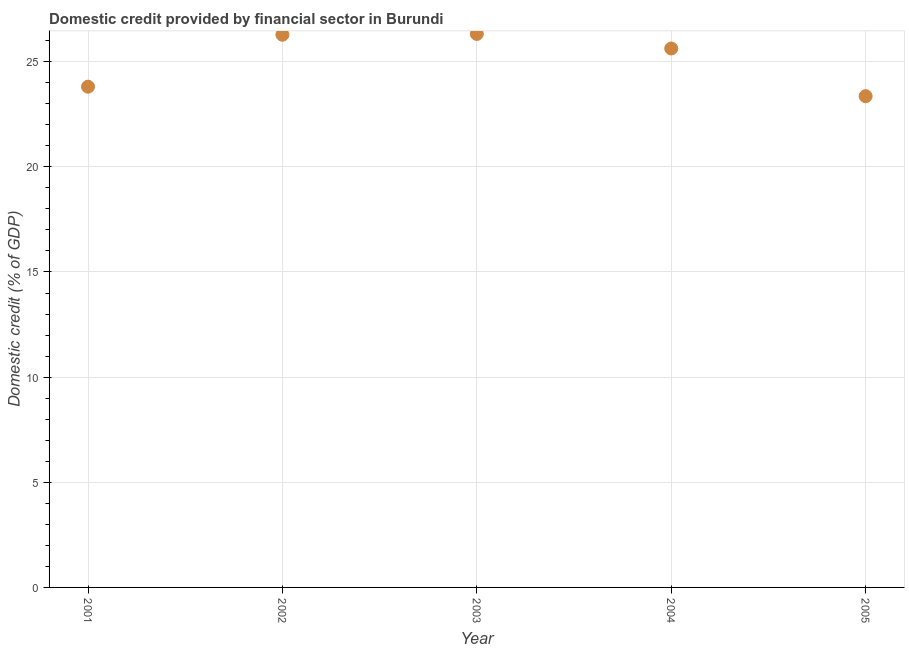What is the domestic credit provided by financial sector in 2002?
Offer a very short reply. 26.28. Across all years, what is the maximum domestic credit provided by financial sector?
Your response must be concise. 26.32. Across all years, what is the minimum domestic credit provided by financial sector?
Make the answer very short. 23.36. What is the sum of the domestic credit provided by financial sector?
Keep it short and to the point. 125.4. What is the difference between the domestic credit provided by financial sector in 2003 and 2004?
Your answer should be very brief. 0.69. What is the average domestic credit provided by financial sector per year?
Ensure brevity in your answer.  25.08. What is the median domestic credit provided by financial sector?
Your answer should be compact. 25.63. In how many years, is the domestic credit provided by financial sector greater than 1 %?
Ensure brevity in your answer.  5. What is the ratio of the domestic credit provided by financial sector in 2002 to that in 2004?
Provide a short and direct response. 1.03. Is the domestic credit provided by financial sector in 2001 less than that in 2003?
Your answer should be very brief. Yes. What is the difference between the highest and the second highest domestic credit provided by financial sector?
Your answer should be very brief. 0.04. What is the difference between the highest and the lowest domestic credit provided by financial sector?
Ensure brevity in your answer.  2.96. How many dotlines are there?
Keep it short and to the point. 1. How many years are there in the graph?
Your response must be concise. 5. What is the title of the graph?
Ensure brevity in your answer.  Domestic credit provided by financial sector in Burundi. What is the label or title of the X-axis?
Provide a succinct answer. Year. What is the label or title of the Y-axis?
Ensure brevity in your answer.  Domestic credit (% of GDP). What is the Domestic credit (% of GDP) in 2001?
Ensure brevity in your answer.  23.81. What is the Domestic credit (% of GDP) in 2002?
Ensure brevity in your answer.  26.28. What is the Domestic credit (% of GDP) in 2003?
Keep it short and to the point. 26.32. What is the Domestic credit (% of GDP) in 2004?
Give a very brief answer. 25.63. What is the Domestic credit (% of GDP) in 2005?
Give a very brief answer. 23.36. What is the difference between the Domestic credit (% of GDP) in 2001 and 2002?
Offer a terse response. -2.47. What is the difference between the Domestic credit (% of GDP) in 2001 and 2003?
Offer a terse response. -2.51. What is the difference between the Domestic credit (% of GDP) in 2001 and 2004?
Provide a short and direct response. -1.82. What is the difference between the Domestic credit (% of GDP) in 2001 and 2005?
Make the answer very short. 0.45. What is the difference between the Domestic credit (% of GDP) in 2002 and 2003?
Make the answer very short. -0.04. What is the difference between the Domestic credit (% of GDP) in 2002 and 2004?
Make the answer very short. 0.65. What is the difference between the Domestic credit (% of GDP) in 2002 and 2005?
Make the answer very short. 2.92. What is the difference between the Domestic credit (% of GDP) in 2003 and 2004?
Offer a terse response. 0.69. What is the difference between the Domestic credit (% of GDP) in 2003 and 2005?
Provide a succinct answer. 2.96. What is the difference between the Domestic credit (% of GDP) in 2004 and 2005?
Give a very brief answer. 2.27. What is the ratio of the Domestic credit (% of GDP) in 2001 to that in 2002?
Keep it short and to the point. 0.91. What is the ratio of the Domestic credit (% of GDP) in 2001 to that in 2003?
Offer a terse response. 0.91. What is the ratio of the Domestic credit (% of GDP) in 2001 to that in 2004?
Your answer should be compact. 0.93. What is the ratio of the Domestic credit (% of GDP) in 2001 to that in 2005?
Offer a very short reply. 1.02. What is the ratio of the Domestic credit (% of GDP) in 2002 to that in 2003?
Give a very brief answer. 1. What is the ratio of the Domestic credit (% of GDP) in 2002 to that in 2004?
Your response must be concise. 1.03. What is the ratio of the Domestic credit (% of GDP) in 2002 to that in 2005?
Make the answer very short. 1.12. What is the ratio of the Domestic credit (% of GDP) in 2003 to that in 2004?
Provide a short and direct response. 1.03. What is the ratio of the Domestic credit (% of GDP) in 2003 to that in 2005?
Offer a terse response. 1.13. What is the ratio of the Domestic credit (% of GDP) in 2004 to that in 2005?
Your response must be concise. 1.1. 